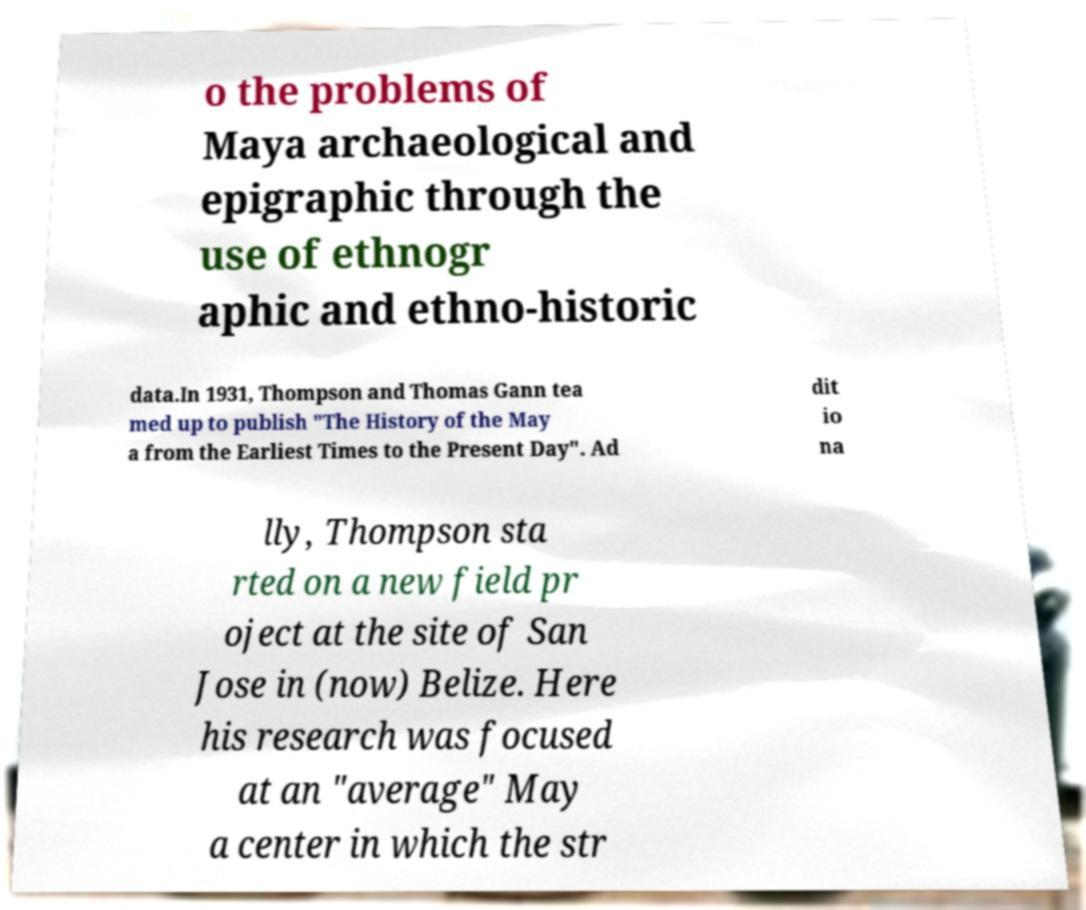Could you assist in decoding the text presented in this image and type it out clearly? o the problems of Maya archaeological and epigraphic through the use of ethnogr aphic and ethno-historic data.In 1931, Thompson and Thomas Gann tea med up to publish "The History of the May a from the Earliest Times to the Present Day". Ad dit io na lly, Thompson sta rted on a new field pr oject at the site of San Jose in (now) Belize. Here his research was focused at an "average" May a center in which the str 